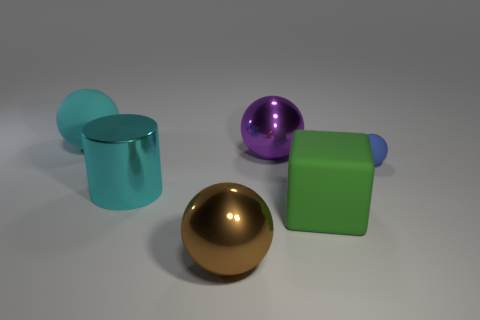Subtract 1 spheres. How many spheres are left? 3 Subtract all cyan balls. How many balls are left? 3 Add 4 cyan objects. How many objects exist? 10 Subtract all yellow spheres. Subtract all green cylinders. How many spheres are left? 4 Subtract all large brown metallic balls. How many balls are left? 3 Subtract all cubes. How many objects are left? 5 Subtract all large cylinders. Subtract all small purple rubber objects. How many objects are left? 5 Add 1 small blue objects. How many small blue objects are left? 2 Add 4 yellow shiny balls. How many yellow shiny balls exist? 4 Subtract 1 brown spheres. How many objects are left? 5 